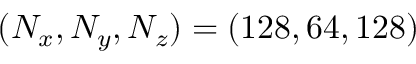<formula> <loc_0><loc_0><loc_500><loc_500>( N _ { x } , N _ { y } , N _ { z } ) = ( 1 2 8 , 6 4 , 1 2 8 )</formula> 